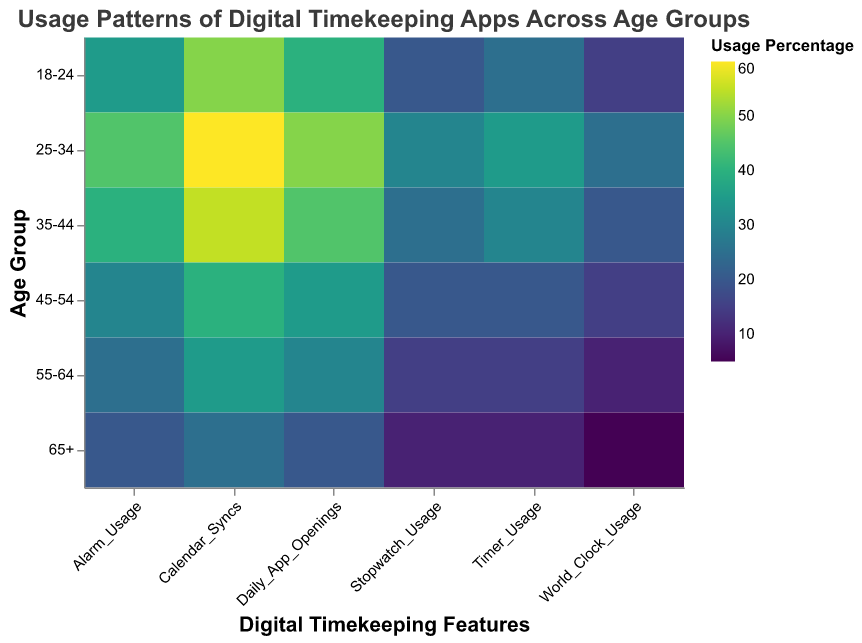what is the highest percentage of daily app openings in any age group? To find the highest percentage of daily app openings, look at the "Daily_App_Openings" column's color shades across different age groups. The darkest shade indicates the highest value. There is a daily app opening percentage of 50% in the 25-34 age group.
Answer: 50% which age group uses the alarm feature the least? To identify the age group with the least alarm usage, look for the lightest color in the "Alarm_Usage" column. The 65+ age group has the lightest color, indicating the lowest usage.
Answer: 65+ what is the difference in calendar syncs between the 18-24 and 65+ age groups? To calculate the difference, note the values for "Calendar_Syncs" in the age groups 18-24 (50) and 65+ (25). Subtract the smaller value from the larger one: 50 - 25 = 25.
Answer: 25 which digital timekeeping feature has the most uniform usage across all age groups? Uniform usage across age groups can be seen when the color variation for that feature is minimal. The "World_Clock_Usage" has the least color variation, indicating relatively uniform usage across all age groups.
Answer: World_Clock_Usage are calendar syncs used more frequently than all other features by the 35-44 age group? To answer this, compare the "Calendar_Syncs" usage (55) with each other feature's usage in the 35-44 age group: Alarm (40), Timer (30), Stopwatch (25), World Clock (20), and Daily App Openings (45). The "Calendar_Syncs" has the highest number, confirming it is used more frequently.
Answer: Yes which age group sees the sharpest decline in alarm usage compared to the previous age group? Examine the "Alarm_Usage" column for decreases between consecutive age groups. The 45-54 age group sees a sharp decline from 40 (35-44 age group) to 30, a drop of 10 percentage points.
Answer: 45-54 how does the timer usage in the 55-64 age group compare to the 18-24 age group? Compare the values of "Timer_Usage" in the 55-64 and 18-24 age groups: 15 and 25, respectively. The 55-64 age group uses the timer feature less than the 18-24 age group.
Answer: Less what is the average stopwatch usage across all age groups? To find the average, sum up the "Stopwatch_Usage" across all age groups: 20 (18-24) + 30 (25-34) + 25 (35-44) + 20 (45-54) + 15 (55-64) + 10 (65+), which equals 120. Divide the total by the number of age groups (6): 120 / 6 = 20.
Answer: 20 is there any age group where the world clock usage is more than the stopwatch usage? Look at the "World_Clock_Usage" and "Stopwatch_Usage" side-by-side for each age group to see if World Clock is higher: none of the age groups shows higher "World_Clock_Usage" than "Stopwatch_Usage".
Answer: No 